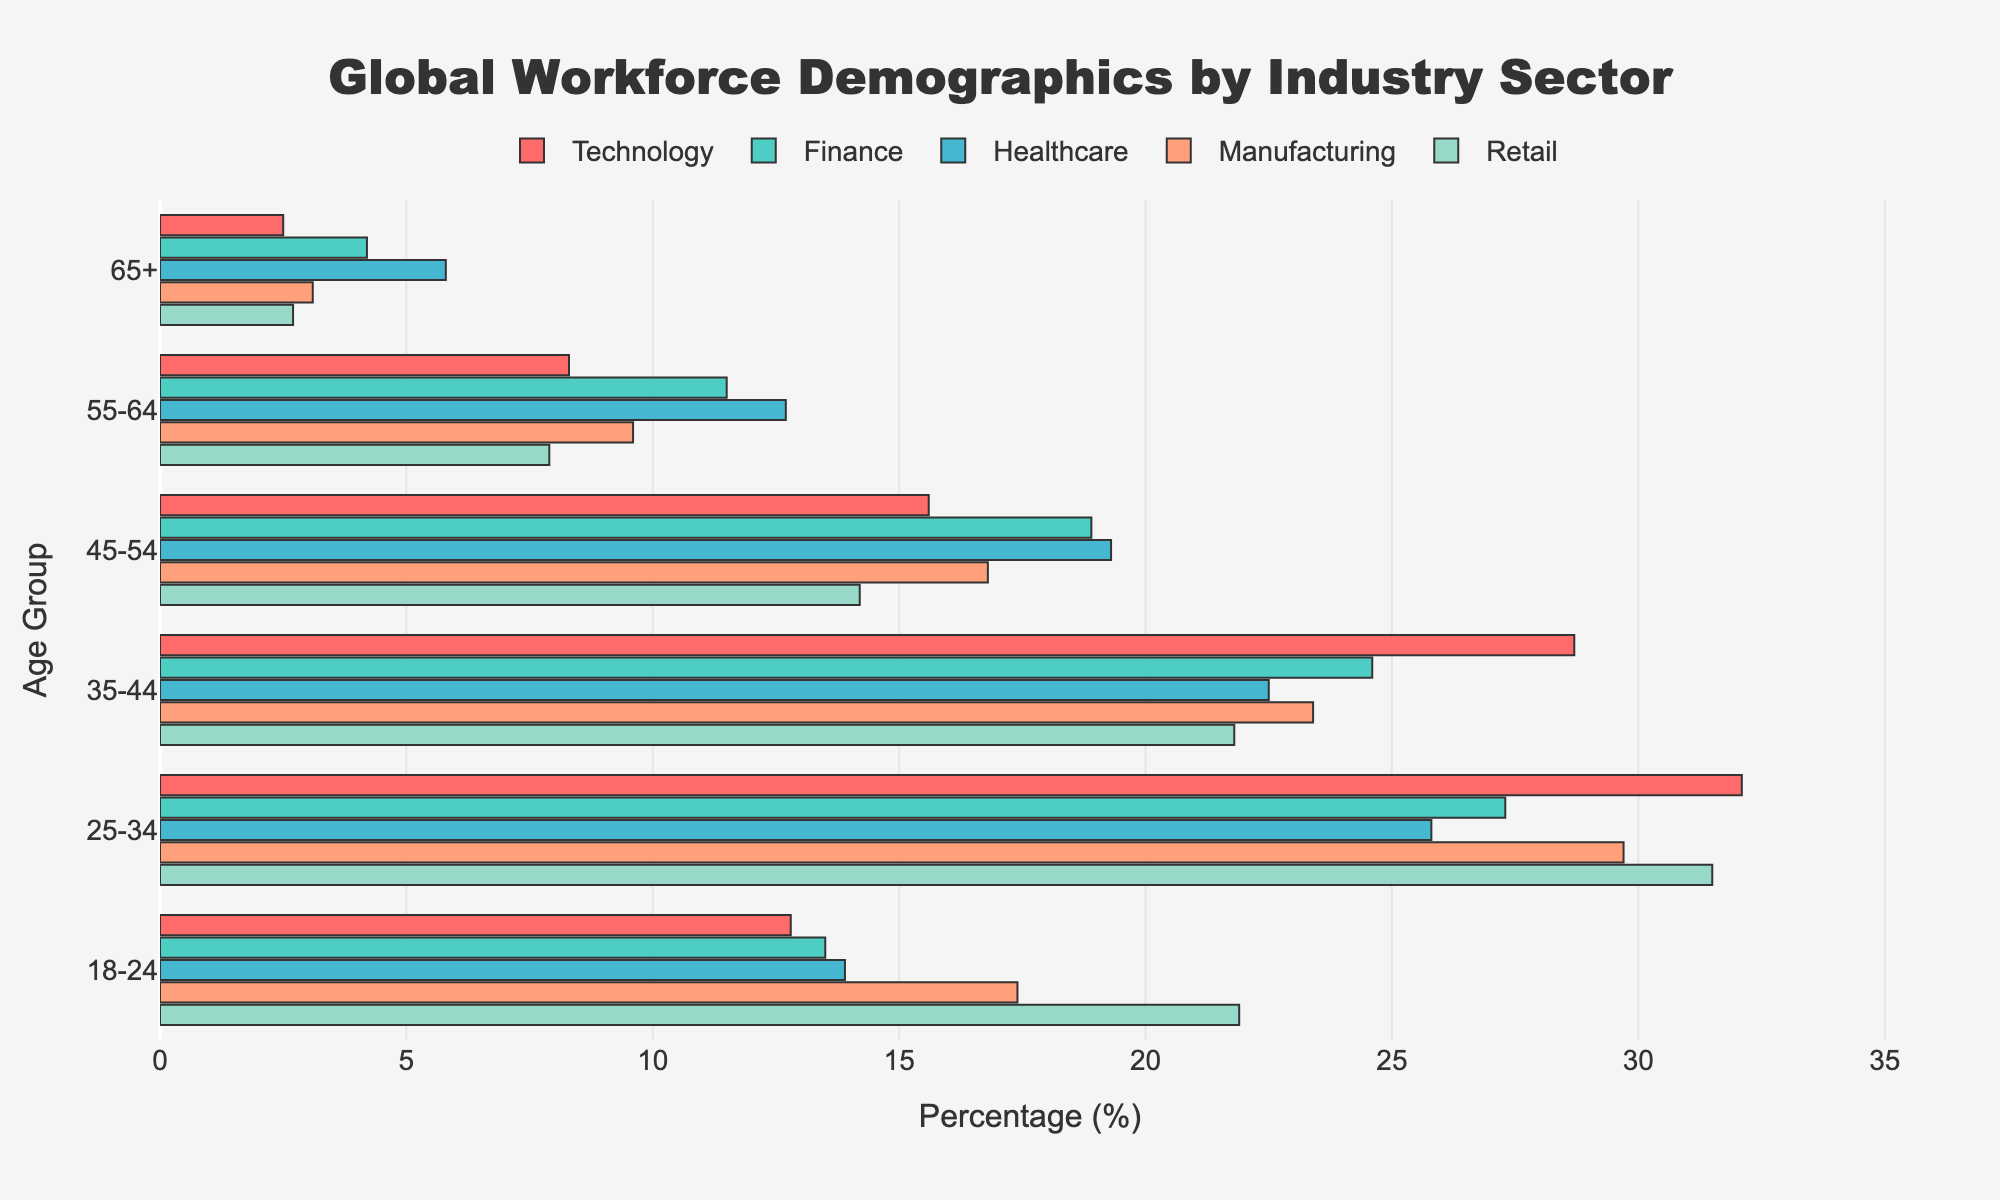What is the title of the figure? The title is located at the top center of the figure, and it textually represents the main focus of the data is the global workforce by industry sector.
Answer: Global Workforce Demographics by Industry Sector Which industry has the highest percentage of workers in the 25-34 age group? Looking for the highest bar in the 25-34 age group, the figure shows that the Technology sector has the highest percentage.
Answer: Technology What's the percentage difference between the 45-54 age group in the Healthcare and Manufacturing sectors? The percentages for the 45-54 age group are 19.3% for Healthcare and 16.8% for Manufacturing. The difference is computed by subtracting these values.
Answer: 2.5% Which age group has the lowest representation in the Retail sector? By comparing the heights of the bars in each age group for Retail, the 65+ age group has the lowest percentage.
Answer: 65+ What is the average percentage of workers in the Finance sector for the 18-24 and 25-34 age groups? For the 18-24 and 25-34 age groups in the Finance sector, the percentages are 13.5% and 27.3%, respectively. The average is calculated by summing these and dividing by 2.
Answer: 20.4% In which sector does the 55-64 age group make up over 12% of the workforce? Reviewing each sector's bar for the 55-64 age group, in the Healthcare sector, it is 12.7%.
Answer: Healthcare Which age group in the Technology sector has a representation close to 30%? Observing the bars in the Technology sector, the 25-34 age group has a representation of 32.1%, which is close to 30%.
Answer: 25-34 Rank the sectors from highest to lowest representation in the 35-44 age group. List the percentages for the 35-44 age group from each sector and rank them. The representations are as follows: Technology (28.7%), Finance (24.6%), Manufacturing (23.4%), Retail (21.8%), Healthcare (22.5%). Hence, the sorted order: Technology, Finance, Manufacturing, Healthcare, Retail.
Answer: Technology > Finance > Manufacturing > Healthcare > Retail What is the combined percentage of the workforce aged 65+ in the Finance and Manufacturing sectors? The percentages for the 65+ age group in Finance and Manufacturing are 4.2% and 3.1%, respectively. Adding these values gives the combined percentage.
Answer: 7.3% In the Retail sector, which age group shows the most significant increase compared to the next youngest age group, 18-24 to 25-34 or 25-34 to 35-44? To determine this, compare the percentage increases. The Retail sector increases from 21.9% to 31.5% (9.6%) when moving from the 18-24 to the 25-34 age group and from 31.5% to 21.8% (-9.7%) from 25-34 to 35-44. The more significant increase is from 18-24 to 25-34.
Answer: 18-24 to 25-34 